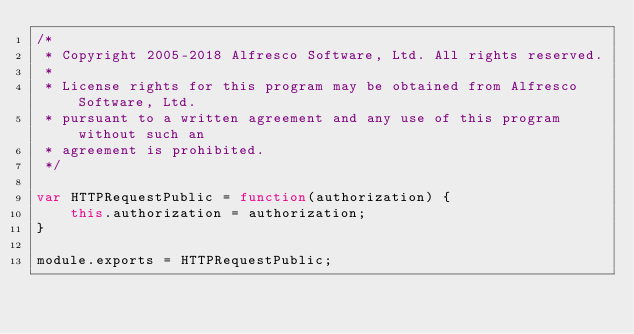<code> <loc_0><loc_0><loc_500><loc_500><_JavaScript_>/*
 * Copyright 2005-2018 Alfresco Software, Ltd. All rights reserved.
 *
 * License rights for this program may be obtained from Alfresco Software, Ltd.
 * pursuant to a written agreement and any use of this program without such an
 * agreement is prohibited.
 */

var HTTPRequestPublic = function(authorization) {
    this.authorization = authorization;
}

module.exports = HTTPRequestPublic;
</code> 